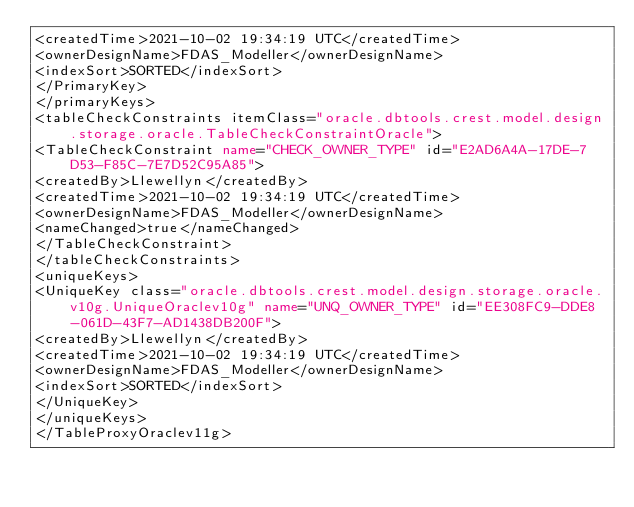Convert code to text. <code><loc_0><loc_0><loc_500><loc_500><_XML_><createdTime>2021-10-02 19:34:19 UTC</createdTime>
<ownerDesignName>FDAS_Modeller</ownerDesignName>
<indexSort>SORTED</indexSort>
</PrimaryKey>
</primaryKeys>
<tableCheckConstraints itemClass="oracle.dbtools.crest.model.design.storage.oracle.TableCheckConstraintOracle">
<TableCheckConstraint name="CHECK_OWNER_TYPE" id="E2AD6A4A-17DE-7D53-F85C-7E7D52C95A85">
<createdBy>Llewellyn</createdBy>
<createdTime>2021-10-02 19:34:19 UTC</createdTime>
<ownerDesignName>FDAS_Modeller</ownerDesignName>
<nameChanged>true</nameChanged>
</TableCheckConstraint>
</tableCheckConstraints>
<uniqueKeys>
<UniqueKey class="oracle.dbtools.crest.model.design.storage.oracle.v10g.UniqueOraclev10g" name="UNQ_OWNER_TYPE" id="EE308FC9-DDE8-061D-43F7-AD1438DB200F">
<createdBy>Llewellyn</createdBy>
<createdTime>2021-10-02 19:34:19 UTC</createdTime>
<ownerDesignName>FDAS_Modeller</ownerDesignName>
<indexSort>SORTED</indexSort>
</UniqueKey>
</uniqueKeys>
</TableProxyOraclev11g>
</code> 